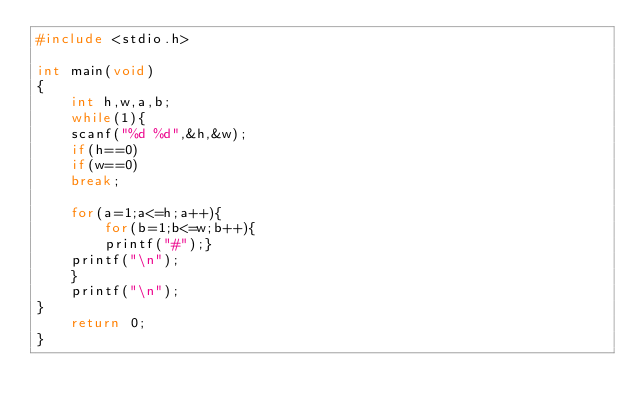<code> <loc_0><loc_0><loc_500><loc_500><_C_>#include <stdio.h>

int main(void)
{
	int h,w,a,b;
	while(1){
	scanf("%d %d",&h,&w);
	if(h==0)
	if(w==0)
	break;
		
	for(a=1;a<=h;a++){
		for(b=1;b<=w;b++){
		printf("#");}
	printf("\n");
	}
	printf("\n");
}
	return 0;
}</code> 